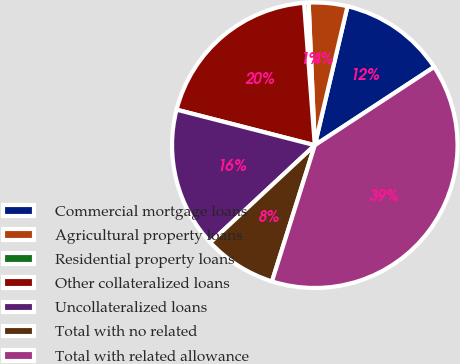Convert chart to OTSL. <chart><loc_0><loc_0><loc_500><loc_500><pie_chart><fcel>Commercial mortgage loans<fcel>Agricultural property loans<fcel>Residential property loans<fcel>Other collateralized loans<fcel>Uncollateralized loans<fcel>Total with no related<fcel>Total with related allowance<nl><fcel>12.08%<fcel>4.37%<fcel>0.51%<fcel>19.79%<fcel>15.94%<fcel>8.22%<fcel>39.09%<nl></chart> 